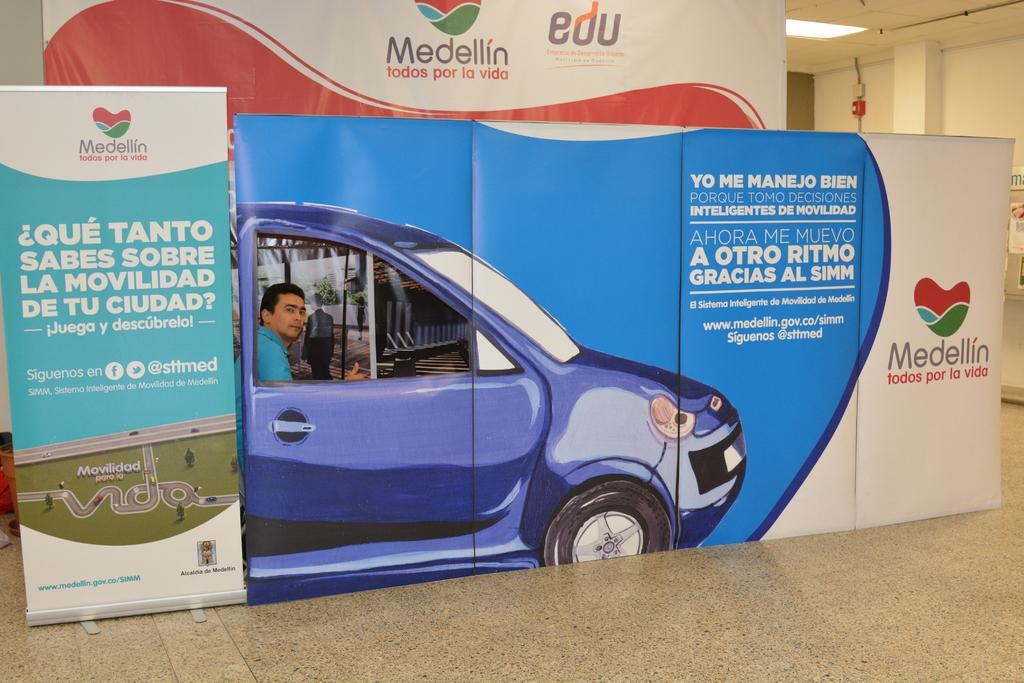Could you give a brief overview of what you see in this image? In this image we can see written text on the board, we can see the floor, one person, there is a wall in the background, ceiling with light. 